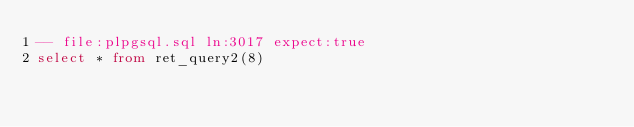Convert code to text. <code><loc_0><loc_0><loc_500><loc_500><_SQL_>-- file:plpgsql.sql ln:3017 expect:true
select * from ret_query2(8)
</code> 